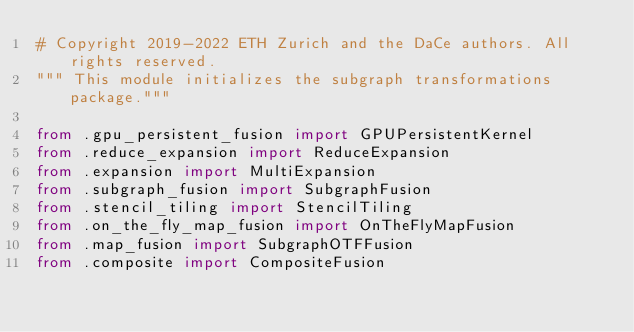<code> <loc_0><loc_0><loc_500><loc_500><_Python_># Copyright 2019-2022 ETH Zurich and the DaCe authors. All rights reserved.
""" This module initializes the subgraph transformations package."""

from .gpu_persistent_fusion import GPUPersistentKernel
from .reduce_expansion import ReduceExpansion
from .expansion import MultiExpansion
from .subgraph_fusion import SubgraphFusion
from .stencil_tiling import StencilTiling
from .on_the_fly_map_fusion import OnTheFlyMapFusion
from .map_fusion import SubgraphOTFFusion
from .composite import CompositeFusion
</code> 